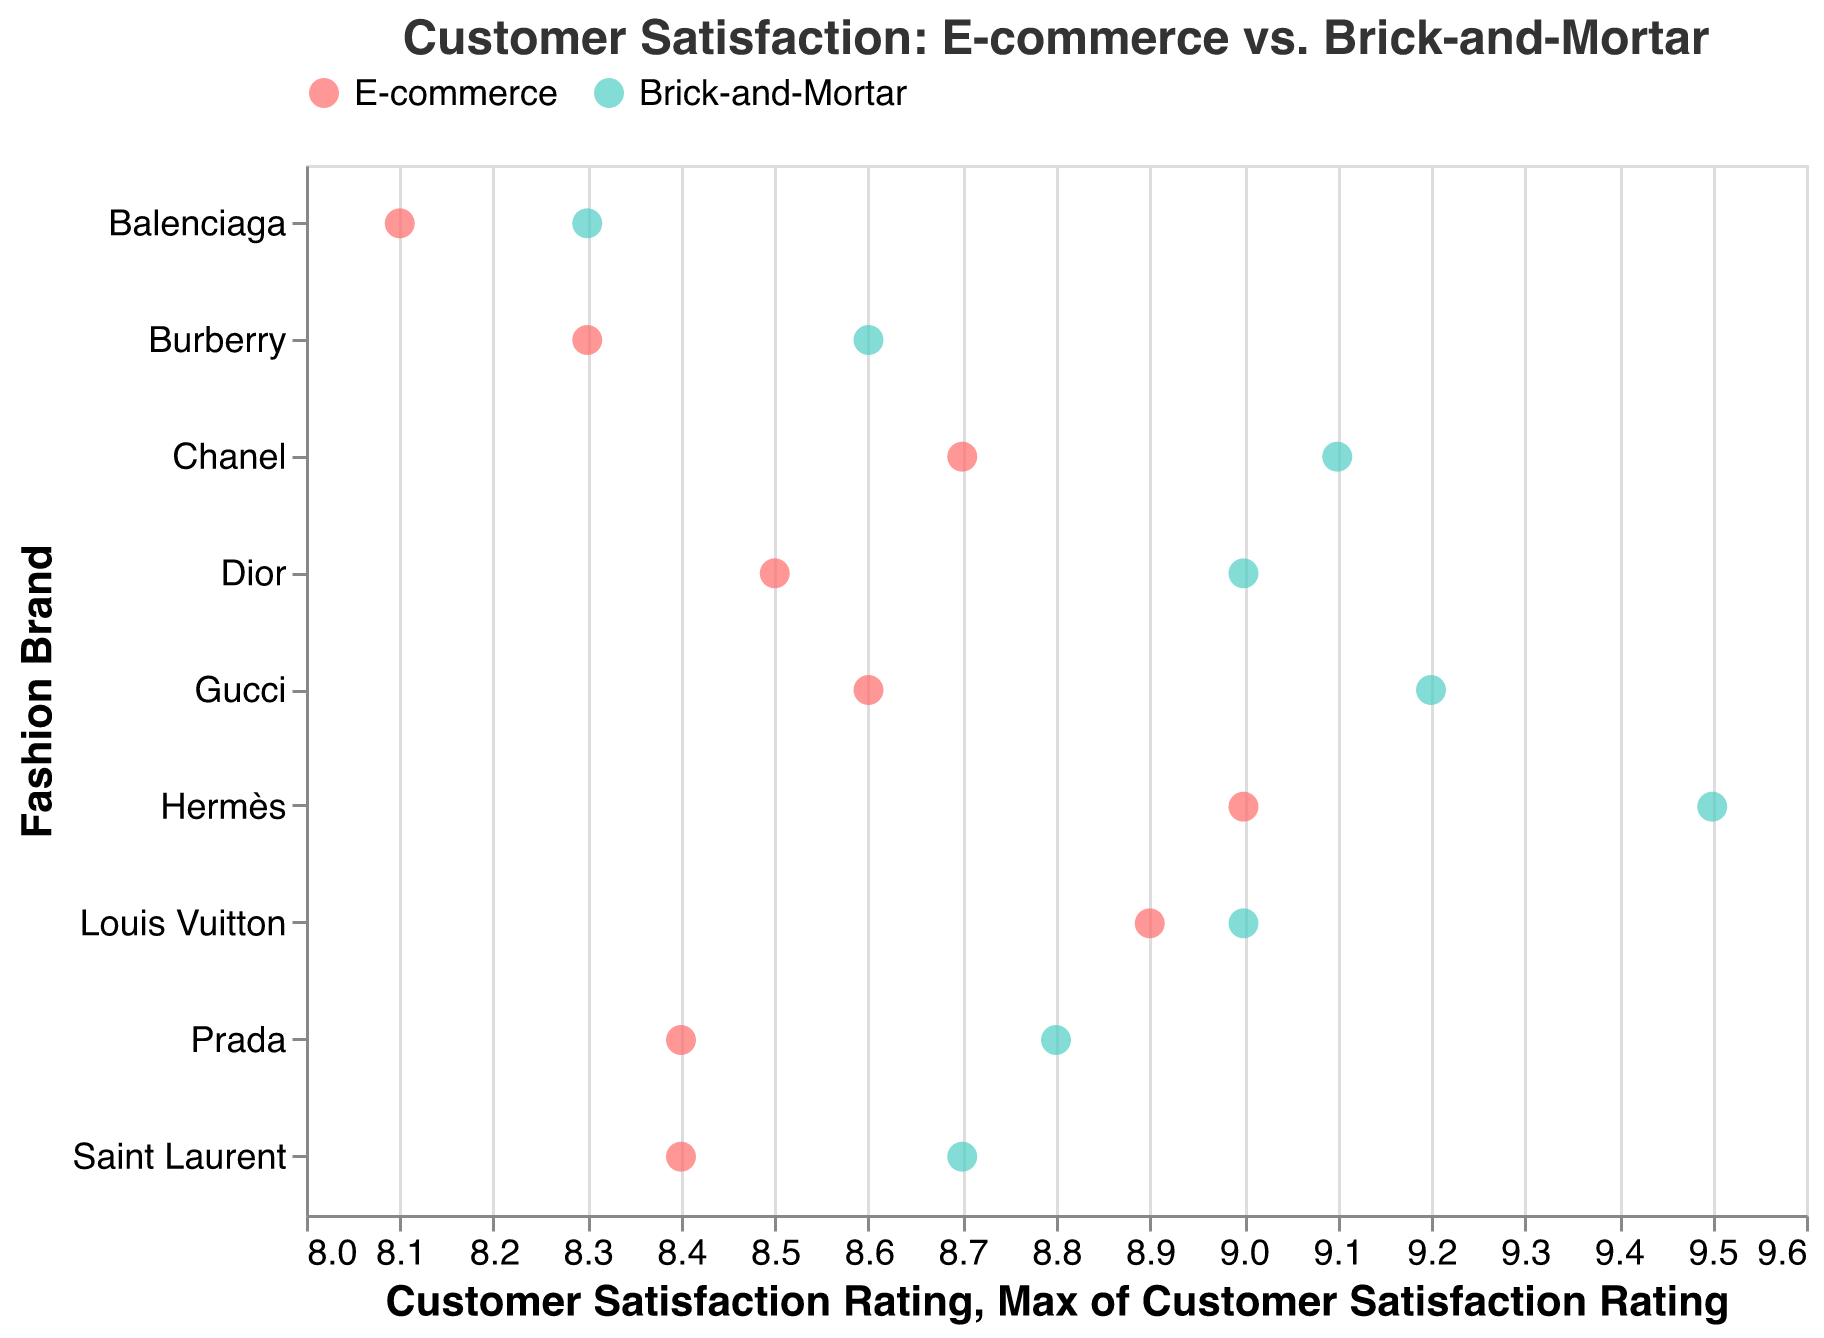What's the title of the figure? The title is usually displayed at the top of the figure. It provides an overview of what the figure demonstrates. In this case, it indicates the figure is about customer satisfaction ratings in different retail channels.
Answer: Customer Satisfaction: E-commerce vs. Brick-and-Mortar How many fashion brands are represented in the figure? Count the unique fashion brands listed on the y-axis. Each brand has two points, one for each retail channel.
Answer: 8 Which fashion brand has the highest customer satisfaction rating in Brick-and-Mortar stores? Look for the brand with the highest point along the x-axis under the Brick-and-Mortar color. This involves finding the maximum rating value and identifying the corresponding brand.
Answer: Hermès What is the difference in customer satisfaction ratings between E-commerce and Brick-and-Mortar channels for Gucci? Identify the Gucci points for both channels and subtract the E-commerce rating from the Brick-and-Mortar rating.
Answer: 0.6 Which retail channel generally has higher customer satisfaction ratings across all brands? Observe the points for both channels and compare the two sets. Note which channel most often has the higher value for each brand.
Answer: Brick-and-Mortar For which brand is the gap in customer satisfaction between E-commerce and Brick-and-Mortar the smallest? Calculate the differences between the two channels for each brand and find the brand with the smallest difference.
Answer: Louis Vuitton What is the average customer satisfaction rating for E-commerce across all brands? Sum all E-commerce ratings and divide by the number of brands. (8.6 + 8.9 + 8.4 + 8.1 + 9.0 + 8.7 + 8.5 + 8.3 + 8.4) = 69.9, then 69.9 / 8 = 8.7375
Answer: 8.7 Which brand has the lowest customer satisfaction rating in E-commerce? Find the E-commerce points and identify the one with the lowest value along the x-axis.
Answer: Balenciaga How much higher is Hermès' customer satisfaction rating in Brick-and-Mortar compared to its E-commerce rating? Subtract the E-commerce rating from the Brick-and-Mortar rating for Hermès. 9.5 - 9.0 = 0.5
Answer: 0.5 Is there any brand where customer satisfaction ratings for E-commerce and Brick-and-Mortar are equal? Check each brand's points for both channels and see if any have identical ratings. If not, then the answer is no.
Answer: No 